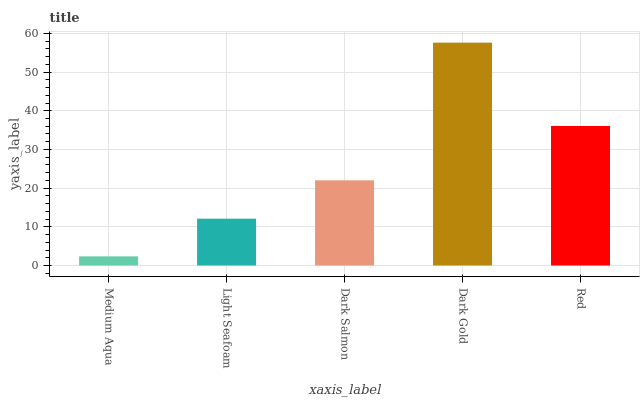Is Medium Aqua the minimum?
Answer yes or no. Yes. Is Dark Gold the maximum?
Answer yes or no. Yes. Is Light Seafoam the minimum?
Answer yes or no. No. Is Light Seafoam the maximum?
Answer yes or no. No. Is Light Seafoam greater than Medium Aqua?
Answer yes or no. Yes. Is Medium Aqua less than Light Seafoam?
Answer yes or no. Yes. Is Medium Aqua greater than Light Seafoam?
Answer yes or no. No. Is Light Seafoam less than Medium Aqua?
Answer yes or no. No. Is Dark Salmon the high median?
Answer yes or no. Yes. Is Dark Salmon the low median?
Answer yes or no. Yes. Is Dark Gold the high median?
Answer yes or no. No. Is Medium Aqua the low median?
Answer yes or no. No. 